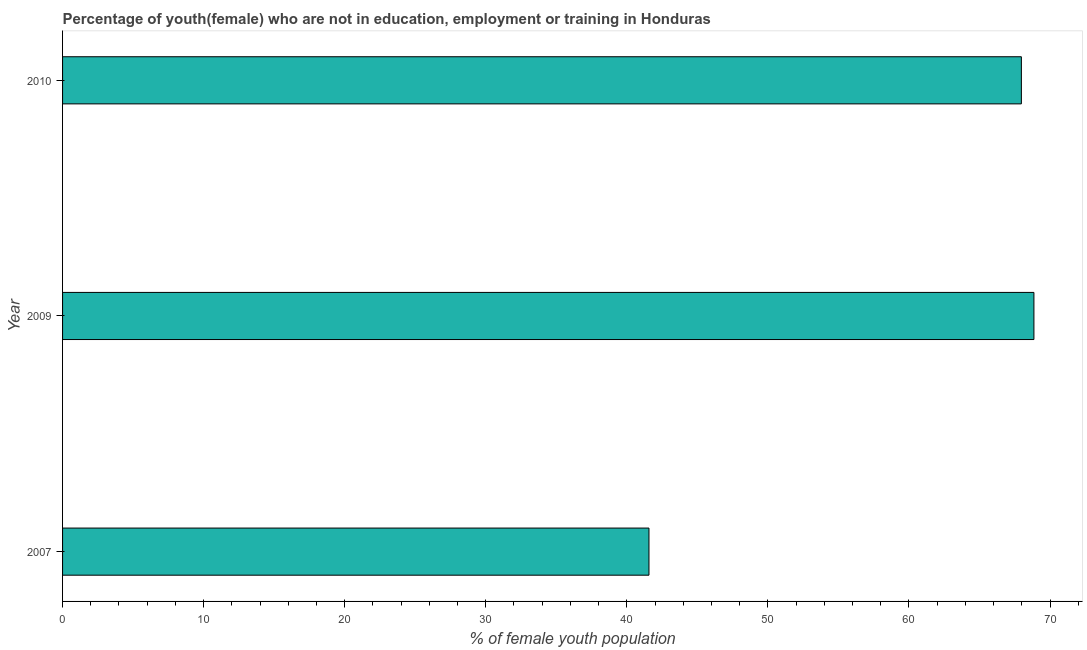Does the graph contain any zero values?
Provide a short and direct response. No. What is the title of the graph?
Offer a very short reply. Percentage of youth(female) who are not in education, employment or training in Honduras. What is the label or title of the X-axis?
Your answer should be compact. % of female youth population. What is the unemployed female youth population in 2009?
Your answer should be compact. 68.86. Across all years, what is the maximum unemployed female youth population?
Offer a very short reply. 68.86. Across all years, what is the minimum unemployed female youth population?
Offer a very short reply. 41.57. In which year was the unemployed female youth population minimum?
Make the answer very short. 2007. What is the sum of the unemployed female youth population?
Make the answer very short. 178.4. What is the difference between the unemployed female youth population in 2009 and 2010?
Provide a short and direct response. 0.89. What is the average unemployed female youth population per year?
Your response must be concise. 59.47. What is the median unemployed female youth population?
Your answer should be very brief. 67.97. In how many years, is the unemployed female youth population greater than 42 %?
Provide a succinct answer. 2. Do a majority of the years between 2009 and 2010 (inclusive) have unemployed female youth population greater than 18 %?
Your answer should be compact. Yes. Is the difference between the unemployed female youth population in 2009 and 2010 greater than the difference between any two years?
Ensure brevity in your answer.  No. What is the difference between the highest and the second highest unemployed female youth population?
Provide a short and direct response. 0.89. What is the difference between the highest and the lowest unemployed female youth population?
Your answer should be very brief. 27.29. How many bars are there?
Provide a short and direct response. 3. How many years are there in the graph?
Keep it short and to the point. 3. What is the difference between two consecutive major ticks on the X-axis?
Offer a terse response. 10. What is the % of female youth population in 2007?
Provide a short and direct response. 41.57. What is the % of female youth population of 2009?
Ensure brevity in your answer.  68.86. What is the % of female youth population in 2010?
Give a very brief answer. 67.97. What is the difference between the % of female youth population in 2007 and 2009?
Ensure brevity in your answer.  -27.29. What is the difference between the % of female youth population in 2007 and 2010?
Ensure brevity in your answer.  -26.4. What is the difference between the % of female youth population in 2009 and 2010?
Your answer should be compact. 0.89. What is the ratio of the % of female youth population in 2007 to that in 2009?
Your response must be concise. 0.6. What is the ratio of the % of female youth population in 2007 to that in 2010?
Ensure brevity in your answer.  0.61. What is the ratio of the % of female youth population in 2009 to that in 2010?
Offer a terse response. 1.01. 